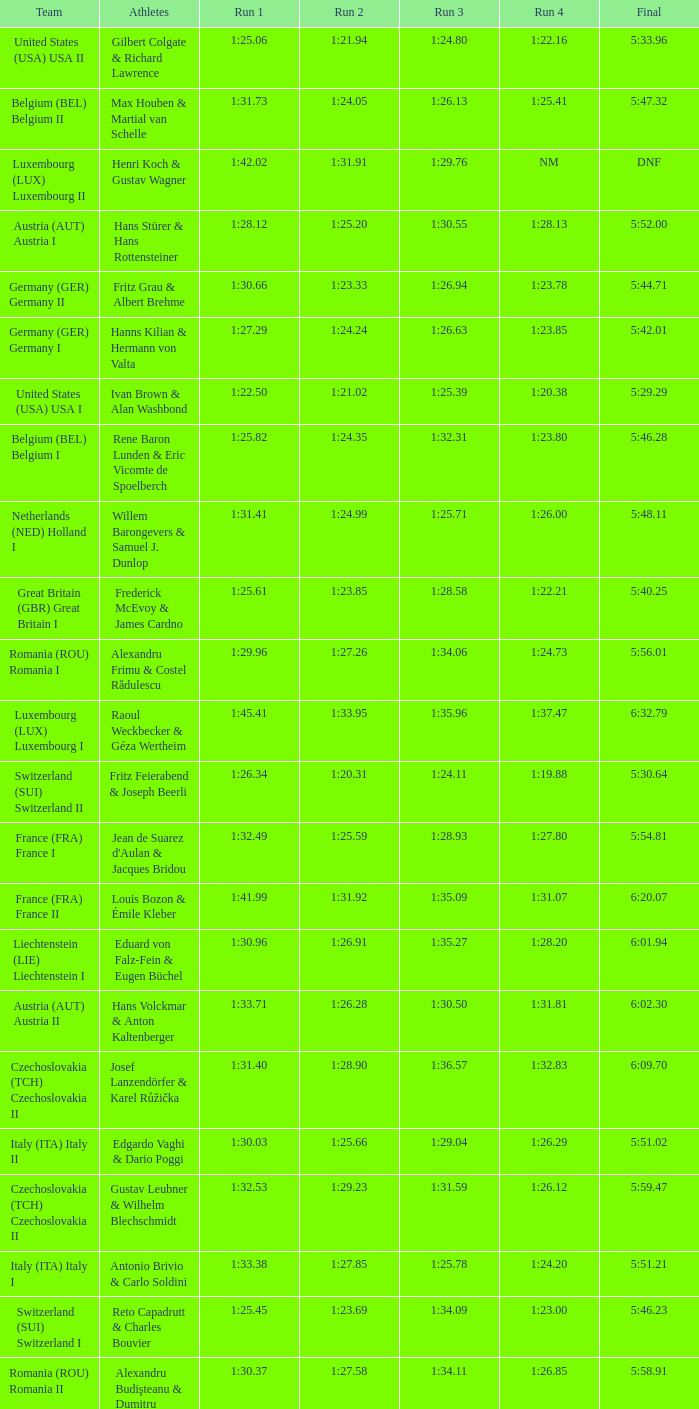Which Run 4 has Athletes of alexandru frimu & costel rădulescu? 1:24.73. 